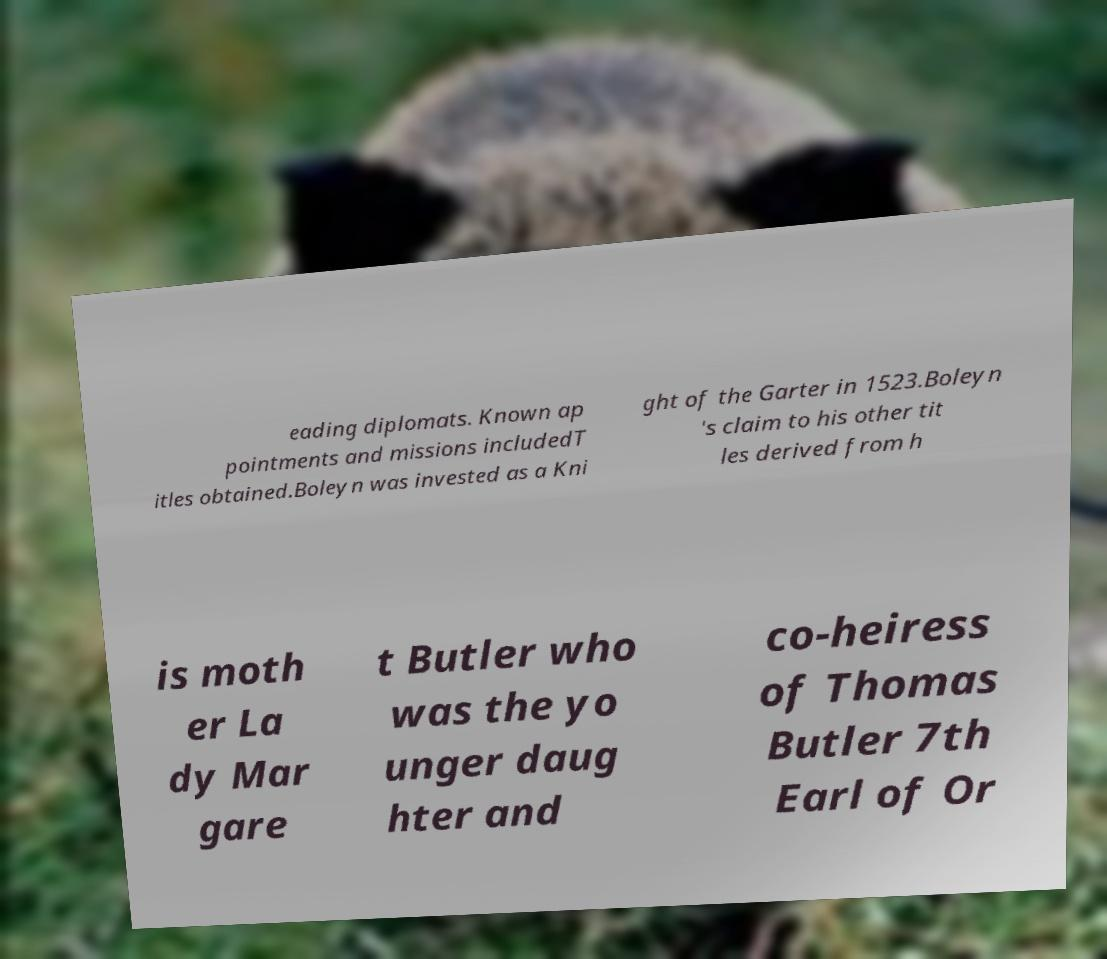Could you assist in decoding the text presented in this image and type it out clearly? eading diplomats. Known ap pointments and missions includedT itles obtained.Boleyn was invested as a Kni ght of the Garter in 1523.Boleyn 's claim to his other tit les derived from h is moth er La dy Mar gare t Butler who was the yo unger daug hter and co-heiress of Thomas Butler 7th Earl of Or 